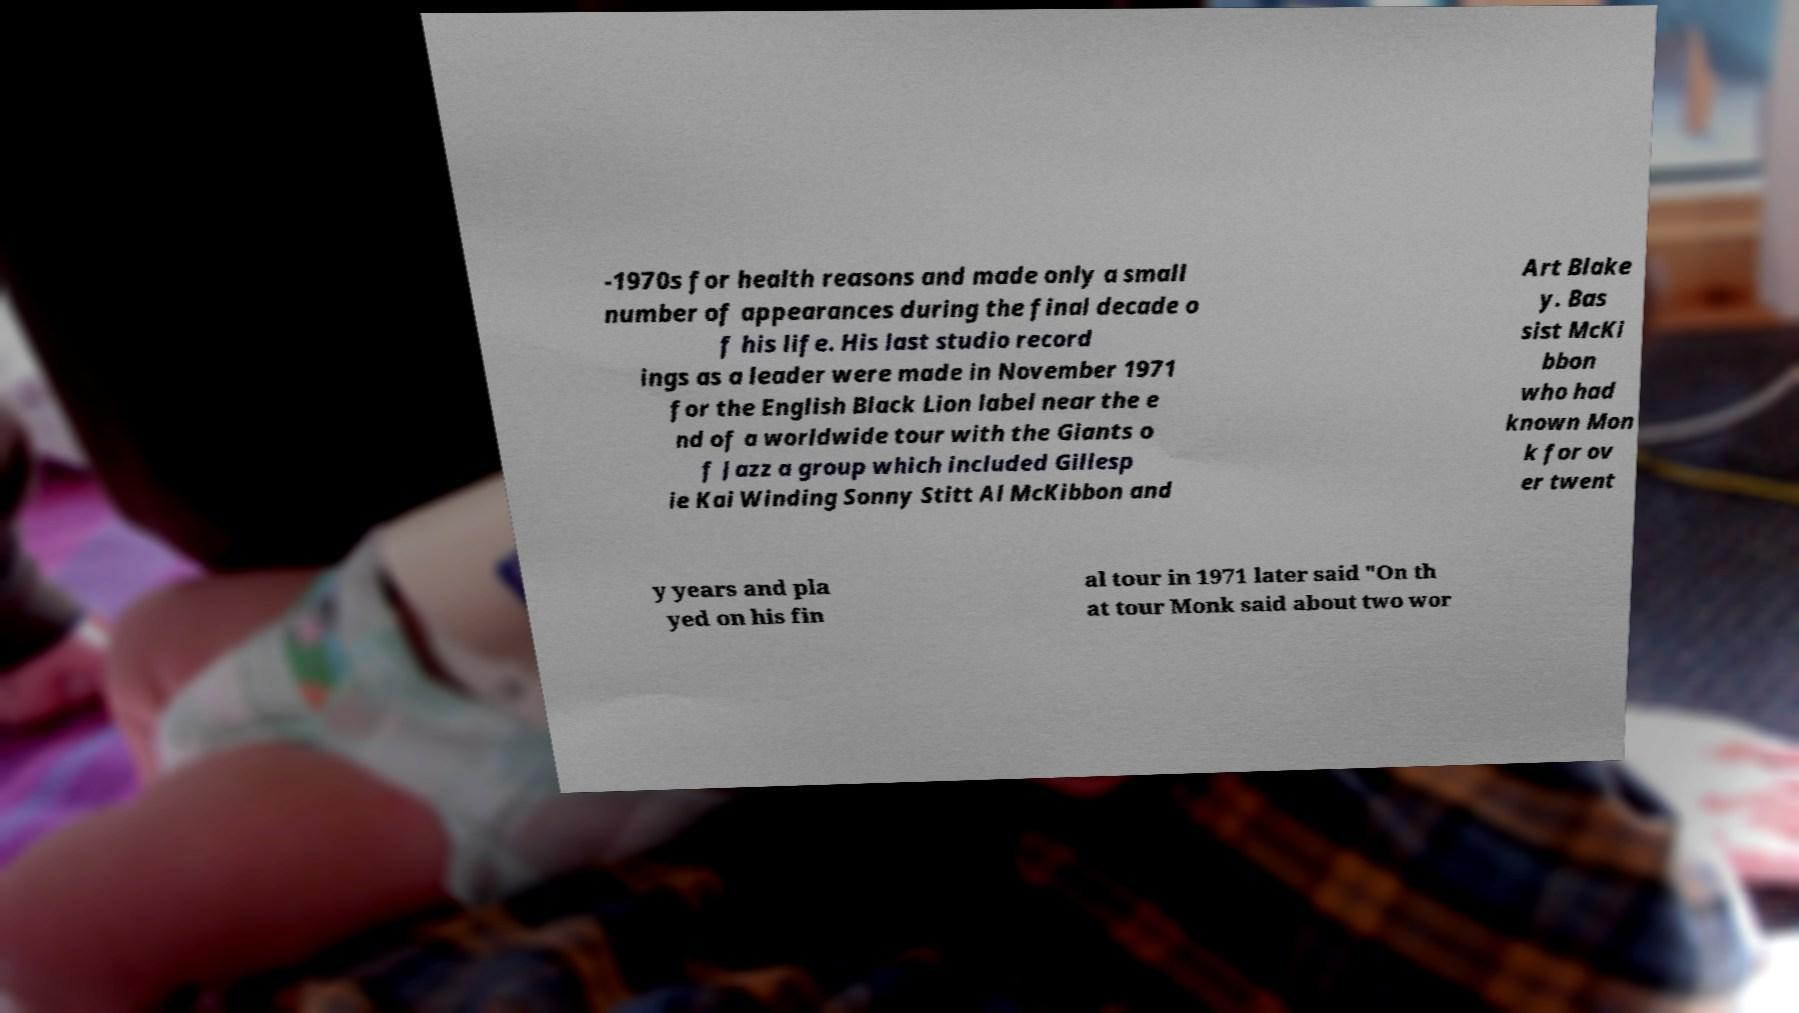For documentation purposes, I need the text within this image transcribed. Could you provide that? -1970s for health reasons and made only a small number of appearances during the final decade o f his life. His last studio record ings as a leader were made in November 1971 for the English Black Lion label near the e nd of a worldwide tour with the Giants o f Jazz a group which included Gillesp ie Kai Winding Sonny Stitt Al McKibbon and Art Blake y. Bas sist McKi bbon who had known Mon k for ov er twent y years and pla yed on his fin al tour in 1971 later said "On th at tour Monk said about two wor 